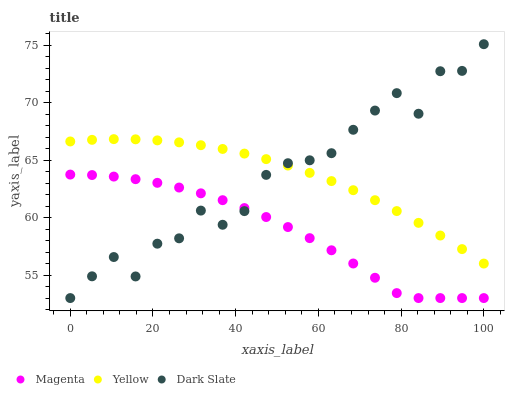Does Magenta have the minimum area under the curve?
Answer yes or no. Yes. Does Yellow have the maximum area under the curve?
Answer yes or no. Yes. Does Yellow have the minimum area under the curve?
Answer yes or no. No. Does Magenta have the maximum area under the curve?
Answer yes or no. No. Is Yellow the smoothest?
Answer yes or no. Yes. Is Dark Slate the roughest?
Answer yes or no. Yes. Is Magenta the smoothest?
Answer yes or no. No. Is Magenta the roughest?
Answer yes or no. No. Does Dark Slate have the lowest value?
Answer yes or no. Yes. Does Yellow have the lowest value?
Answer yes or no. No. Does Dark Slate have the highest value?
Answer yes or no. Yes. Does Yellow have the highest value?
Answer yes or no. No. Is Magenta less than Yellow?
Answer yes or no. Yes. Is Yellow greater than Magenta?
Answer yes or no. Yes. Does Dark Slate intersect Yellow?
Answer yes or no. Yes. Is Dark Slate less than Yellow?
Answer yes or no. No. Is Dark Slate greater than Yellow?
Answer yes or no. No. Does Magenta intersect Yellow?
Answer yes or no. No. 